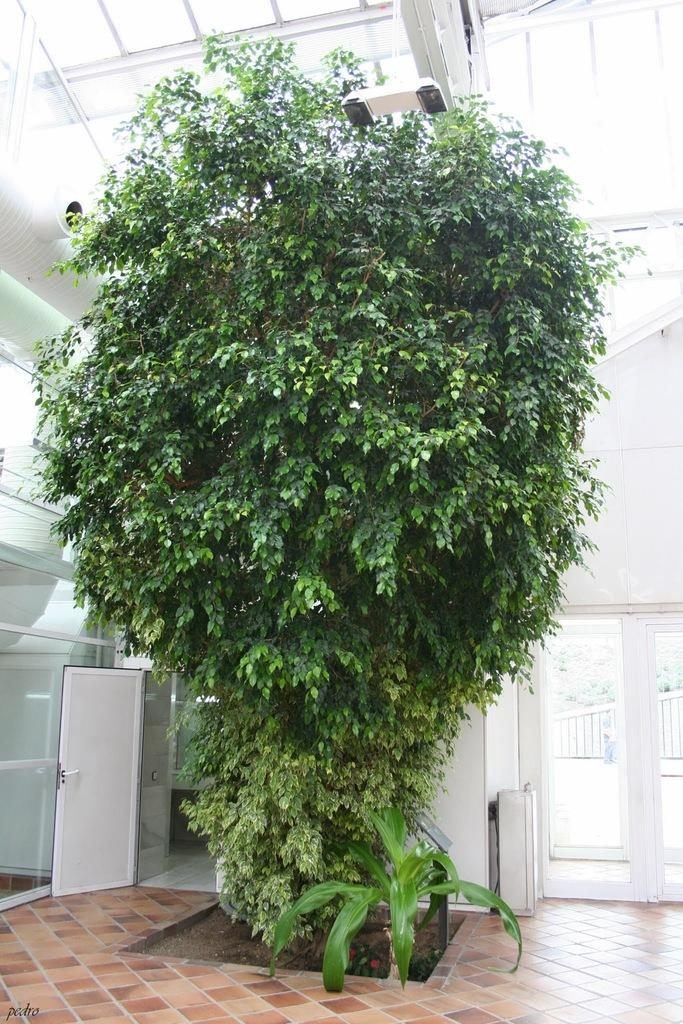What is the main feature in the front of the image? There is a huge green plant in the front of the image. What type of door can be seen in the image? There is a glass door in the image. What color is the wall visible in the image? There is a white wall in the image. What structure is located on the top of the image? There is a glass shed on the top of the image. What is the rate of the coughing sound coming from the plant in the image? There is no coughing sound coming from the plant in the image, as plants do not produce such sounds. 